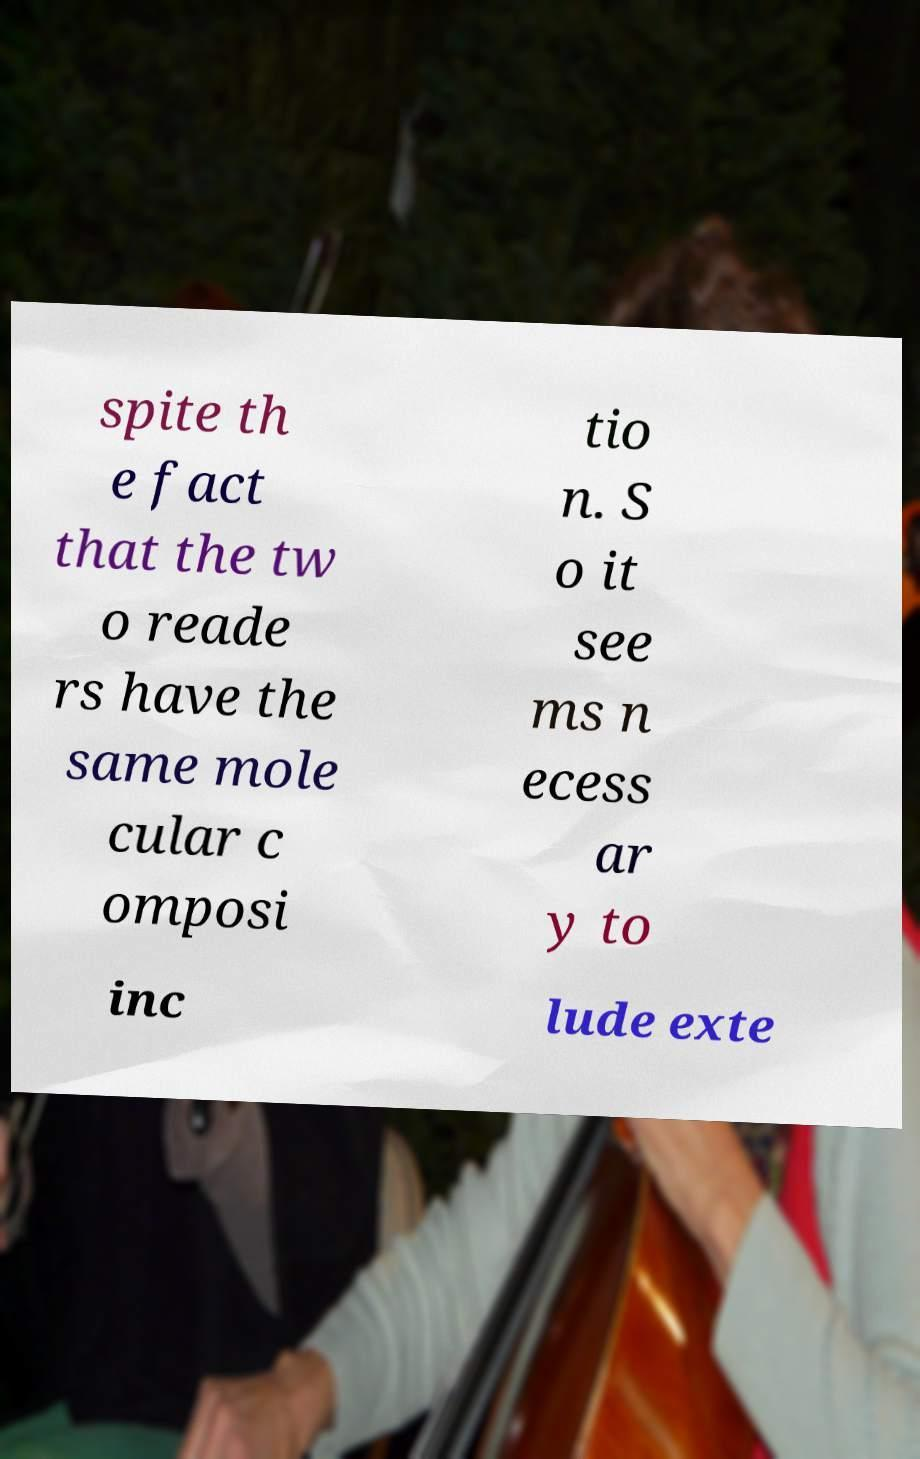Please identify and transcribe the text found in this image. spite th e fact that the tw o reade rs have the same mole cular c omposi tio n. S o it see ms n ecess ar y to inc lude exte 